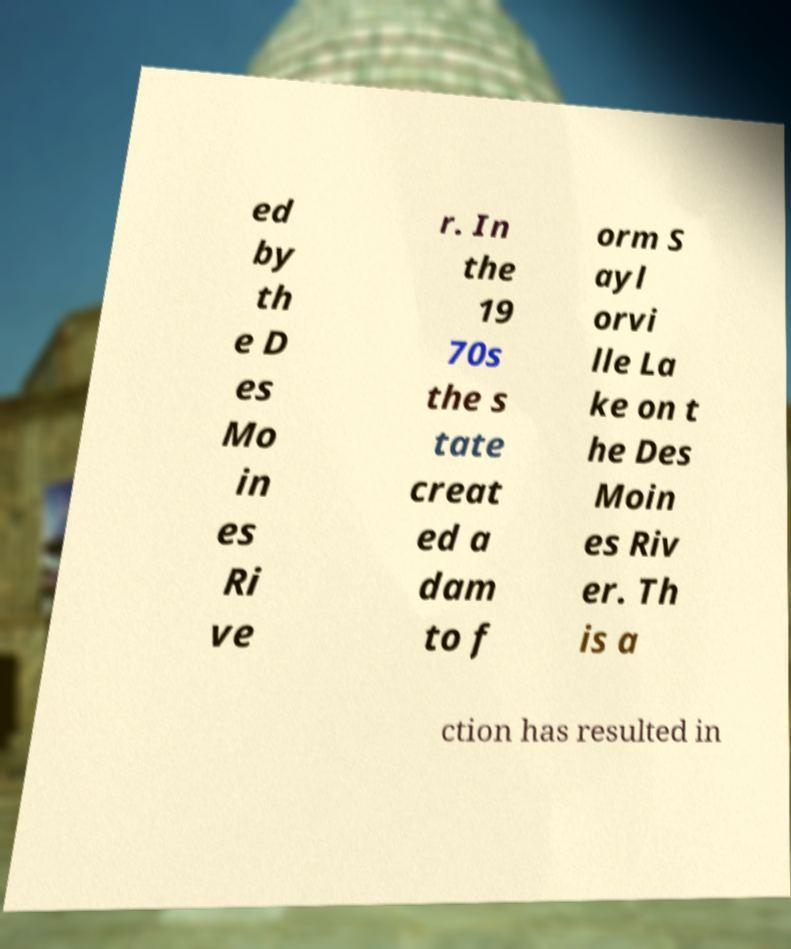For documentation purposes, I need the text within this image transcribed. Could you provide that? ed by th e D es Mo in es Ri ve r. In the 19 70s the s tate creat ed a dam to f orm S ayl orvi lle La ke on t he Des Moin es Riv er. Th is a ction has resulted in 